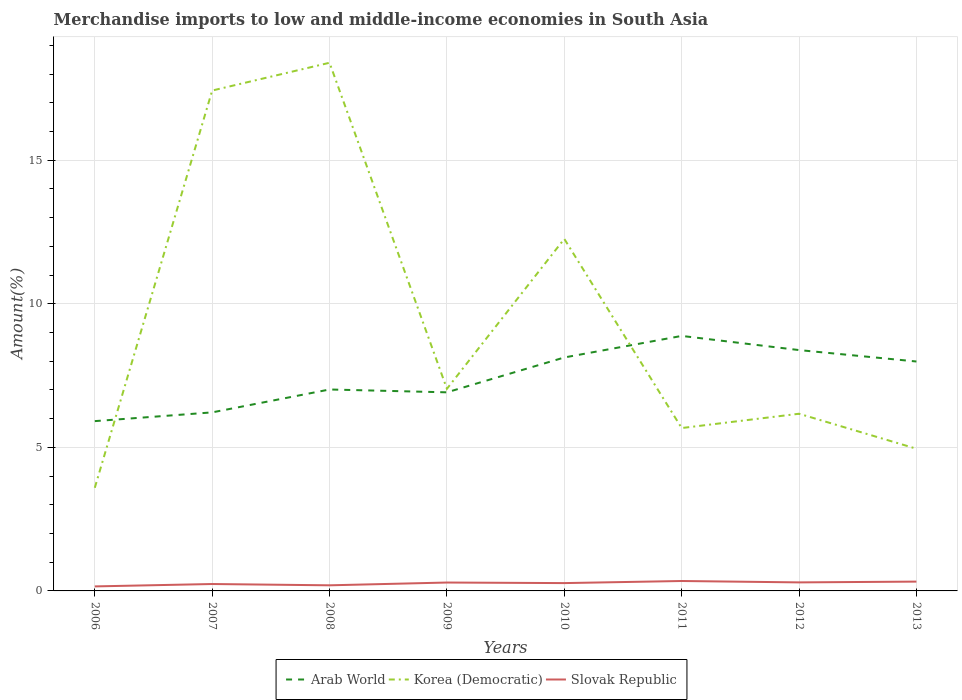Across all years, what is the maximum percentage of amount earned from merchandise imports in Arab World?
Offer a very short reply. 5.91. In which year was the percentage of amount earned from merchandise imports in Arab World maximum?
Ensure brevity in your answer.  2006. What is the total percentage of amount earned from merchandise imports in Arab World in the graph?
Make the answer very short. -1.07. What is the difference between the highest and the second highest percentage of amount earned from merchandise imports in Slovak Republic?
Offer a terse response. 0.19. Is the percentage of amount earned from merchandise imports in Arab World strictly greater than the percentage of amount earned from merchandise imports in Slovak Republic over the years?
Keep it short and to the point. No. Are the values on the major ticks of Y-axis written in scientific E-notation?
Give a very brief answer. No. Where does the legend appear in the graph?
Your response must be concise. Bottom center. How many legend labels are there?
Your response must be concise. 3. What is the title of the graph?
Provide a succinct answer. Merchandise imports to low and middle-income economies in South Asia. What is the label or title of the Y-axis?
Offer a very short reply. Amount(%). What is the Amount(%) of Arab World in 2006?
Ensure brevity in your answer.  5.91. What is the Amount(%) of Korea (Democratic) in 2006?
Ensure brevity in your answer.  3.59. What is the Amount(%) of Slovak Republic in 2006?
Your response must be concise. 0.16. What is the Amount(%) in Arab World in 2007?
Give a very brief answer. 6.22. What is the Amount(%) of Korea (Democratic) in 2007?
Provide a succinct answer. 17.43. What is the Amount(%) of Slovak Republic in 2007?
Offer a very short reply. 0.24. What is the Amount(%) of Arab World in 2008?
Provide a short and direct response. 7.01. What is the Amount(%) in Korea (Democratic) in 2008?
Your response must be concise. 18.39. What is the Amount(%) of Slovak Republic in 2008?
Keep it short and to the point. 0.2. What is the Amount(%) of Arab World in 2009?
Keep it short and to the point. 6.92. What is the Amount(%) of Korea (Democratic) in 2009?
Offer a very short reply. 7.04. What is the Amount(%) of Slovak Republic in 2009?
Ensure brevity in your answer.  0.29. What is the Amount(%) in Arab World in 2010?
Provide a succinct answer. 8.13. What is the Amount(%) of Korea (Democratic) in 2010?
Provide a short and direct response. 12.26. What is the Amount(%) of Slovak Republic in 2010?
Make the answer very short. 0.27. What is the Amount(%) in Arab World in 2011?
Offer a terse response. 8.88. What is the Amount(%) in Korea (Democratic) in 2011?
Ensure brevity in your answer.  5.67. What is the Amount(%) of Slovak Republic in 2011?
Your answer should be very brief. 0.35. What is the Amount(%) in Arab World in 2012?
Offer a very short reply. 8.39. What is the Amount(%) of Korea (Democratic) in 2012?
Ensure brevity in your answer.  6.17. What is the Amount(%) in Slovak Republic in 2012?
Ensure brevity in your answer.  0.3. What is the Amount(%) of Arab World in 2013?
Give a very brief answer. 7.99. What is the Amount(%) of Korea (Democratic) in 2013?
Provide a short and direct response. 4.95. What is the Amount(%) of Slovak Republic in 2013?
Provide a short and direct response. 0.32. Across all years, what is the maximum Amount(%) of Arab World?
Your answer should be very brief. 8.88. Across all years, what is the maximum Amount(%) in Korea (Democratic)?
Your answer should be very brief. 18.39. Across all years, what is the maximum Amount(%) of Slovak Republic?
Give a very brief answer. 0.35. Across all years, what is the minimum Amount(%) in Arab World?
Your answer should be very brief. 5.91. Across all years, what is the minimum Amount(%) of Korea (Democratic)?
Provide a short and direct response. 3.59. Across all years, what is the minimum Amount(%) of Slovak Republic?
Make the answer very short. 0.16. What is the total Amount(%) of Arab World in the graph?
Ensure brevity in your answer.  59.45. What is the total Amount(%) in Korea (Democratic) in the graph?
Provide a succinct answer. 75.5. What is the total Amount(%) in Slovak Republic in the graph?
Ensure brevity in your answer.  2.13. What is the difference between the Amount(%) of Arab World in 2006 and that in 2007?
Make the answer very short. -0.3. What is the difference between the Amount(%) of Korea (Democratic) in 2006 and that in 2007?
Give a very brief answer. -13.83. What is the difference between the Amount(%) of Slovak Republic in 2006 and that in 2007?
Ensure brevity in your answer.  -0.08. What is the difference between the Amount(%) of Arab World in 2006 and that in 2008?
Ensure brevity in your answer.  -1.1. What is the difference between the Amount(%) of Korea (Democratic) in 2006 and that in 2008?
Give a very brief answer. -14.8. What is the difference between the Amount(%) in Slovak Republic in 2006 and that in 2008?
Give a very brief answer. -0.04. What is the difference between the Amount(%) in Arab World in 2006 and that in 2009?
Offer a terse response. -1. What is the difference between the Amount(%) in Korea (Democratic) in 2006 and that in 2009?
Keep it short and to the point. -3.45. What is the difference between the Amount(%) in Slovak Republic in 2006 and that in 2009?
Your answer should be very brief. -0.13. What is the difference between the Amount(%) of Arab World in 2006 and that in 2010?
Make the answer very short. -2.22. What is the difference between the Amount(%) in Korea (Democratic) in 2006 and that in 2010?
Make the answer very short. -8.67. What is the difference between the Amount(%) of Slovak Republic in 2006 and that in 2010?
Your response must be concise. -0.12. What is the difference between the Amount(%) of Arab World in 2006 and that in 2011?
Offer a terse response. -2.97. What is the difference between the Amount(%) of Korea (Democratic) in 2006 and that in 2011?
Offer a terse response. -2.08. What is the difference between the Amount(%) in Slovak Republic in 2006 and that in 2011?
Provide a short and direct response. -0.19. What is the difference between the Amount(%) of Arab World in 2006 and that in 2012?
Provide a succinct answer. -2.47. What is the difference between the Amount(%) in Korea (Democratic) in 2006 and that in 2012?
Your response must be concise. -2.58. What is the difference between the Amount(%) of Slovak Republic in 2006 and that in 2012?
Ensure brevity in your answer.  -0.14. What is the difference between the Amount(%) of Arab World in 2006 and that in 2013?
Your answer should be compact. -2.08. What is the difference between the Amount(%) in Korea (Democratic) in 2006 and that in 2013?
Your response must be concise. -1.36. What is the difference between the Amount(%) of Slovak Republic in 2006 and that in 2013?
Provide a short and direct response. -0.17. What is the difference between the Amount(%) in Arab World in 2007 and that in 2008?
Your answer should be compact. -0.8. What is the difference between the Amount(%) in Korea (Democratic) in 2007 and that in 2008?
Provide a short and direct response. -0.97. What is the difference between the Amount(%) in Slovak Republic in 2007 and that in 2008?
Your answer should be compact. 0.05. What is the difference between the Amount(%) in Arab World in 2007 and that in 2009?
Provide a short and direct response. -0.7. What is the difference between the Amount(%) in Korea (Democratic) in 2007 and that in 2009?
Your response must be concise. 10.39. What is the difference between the Amount(%) of Slovak Republic in 2007 and that in 2009?
Provide a succinct answer. -0.05. What is the difference between the Amount(%) of Arab World in 2007 and that in 2010?
Give a very brief answer. -1.91. What is the difference between the Amount(%) in Korea (Democratic) in 2007 and that in 2010?
Give a very brief answer. 5.17. What is the difference between the Amount(%) of Slovak Republic in 2007 and that in 2010?
Your answer should be very brief. -0.03. What is the difference between the Amount(%) of Arab World in 2007 and that in 2011?
Keep it short and to the point. -2.66. What is the difference between the Amount(%) in Korea (Democratic) in 2007 and that in 2011?
Ensure brevity in your answer.  11.75. What is the difference between the Amount(%) of Slovak Republic in 2007 and that in 2011?
Provide a short and direct response. -0.1. What is the difference between the Amount(%) of Arab World in 2007 and that in 2012?
Your answer should be very brief. -2.17. What is the difference between the Amount(%) in Korea (Democratic) in 2007 and that in 2012?
Your answer should be very brief. 11.26. What is the difference between the Amount(%) in Slovak Republic in 2007 and that in 2012?
Your response must be concise. -0.06. What is the difference between the Amount(%) in Arab World in 2007 and that in 2013?
Give a very brief answer. -1.77. What is the difference between the Amount(%) in Korea (Democratic) in 2007 and that in 2013?
Your answer should be very brief. 12.47. What is the difference between the Amount(%) of Slovak Republic in 2007 and that in 2013?
Your response must be concise. -0.08. What is the difference between the Amount(%) of Arab World in 2008 and that in 2009?
Offer a very short reply. 0.1. What is the difference between the Amount(%) in Korea (Democratic) in 2008 and that in 2009?
Your response must be concise. 11.35. What is the difference between the Amount(%) in Slovak Republic in 2008 and that in 2009?
Your answer should be very brief. -0.1. What is the difference between the Amount(%) in Arab World in 2008 and that in 2010?
Make the answer very short. -1.11. What is the difference between the Amount(%) of Korea (Democratic) in 2008 and that in 2010?
Your answer should be compact. 6.13. What is the difference between the Amount(%) of Slovak Republic in 2008 and that in 2010?
Your answer should be very brief. -0.08. What is the difference between the Amount(%) in Arab World in 2008 and that in 2011?
Offer a terse response. -1.87. What is the difference between the Amount(%) in Korea (Democratic) in 2008 and that in 2011?
Provide a short and direct response. 12.72. What is the difference between the Amount(%) in Slovak Republic in 2008 and that in 2011?
Ensure brevity in your answer.  -0.15. What is the difference between the Amount(%) in Arab World in 2008 and that in 2012?
Your answer should be very brief. -1.37. What is the difference between the Amount(%) in Korea (Democratic) in 2008 and that in 2012?
Your answer should be very brief. 12.22. What is the difference between the Amount(%) of Slovak Republic in 2008 and that in 2012?
Your answer should be compact. -0.1. What is the difference between the Amount(%) in Arab World in 2008 and that in 2013?
Give a very brief answer. -0.97. What is the difference between the Amount(%) in Korea (Democratic) in 2008 and that in 2013?
Make the answer very short. 13.44. What is the difference between the Amount(%) of Slovak Republic in 2008 and that in 2013?
Provide a short and direct response. -0.13. What is the difference between the Amount(%) of Arab World in 2009 and that in 2010?
Ensure brevity in your answer.  -1.21. What is the difference between the Amount(%) of Korea (Democratic) in 2009 and that in 2010?
Give a very brief answer. -5.22. What is the difference between the Amount(%) of Slovak Republic in 2009 and that in 2010?
Your answer should be very brief. 0.02. What is the difference between the Amount(%) of Arab World in 2009 and that in 2011?
Give a very brief answer. -1.96. What is the difference between the Amount(%) of Korea (Democratic) in 2009 and that in 2011?
Provide a short and direct response. 1.37. What is the difference between the Amount(%) in Slovak Republic in 2009 and that in 2011?
Your response must be concise. -0.05. What is the difference between the Amount(%) of Arab World in 2009 and that in 2012?
Offer a terse response. -1.47. What is the difference between the Amount(%) in Korea (Democratic) in 2009 and that in 2012?
Provide a succinct answer. 0.87. What is the difference between the Amount(%) in Slovak Republic in 2009 and that in 2012?
Offer a terse response. -0.01. What is the difference between the Amount(%) in Arab World in 2009 and that in 2013?
Your response must be concise. -1.07. What is the difference between the Amount(%) of Korea (Democratic) in 2009 and that in 2013?
Your answer should be very brief. 2.09. What is the difference between the Amount(%) in Slovak Republic in 2009 and that in 2013?
Keep it short and to the point. -0.03. What is the difference between the Amount(%) in Arab World in 2010 and that in 2011?
Make the answer very short. -0.75. What is the difference between the Amount(%) of Korea (Democratic) in 2010 and that in 2011?
Your answer should be very brief. 6.59. What is the difference between the Amount(%) of Slovak Republic in 2010 and that in 2011?
Your answer should be compact. -0.07. What is the difference between the Amount(%) in Arab World in 2010 and that in 2012?
Provide a short and direct response. -0.26. What is the difference between the Amount(%) of Korea (Democratic) in 2010 and that in 2012?
Ensure brevity in your answer.  6.09. What is the difference between the Amount(%) in Slovak Republic in 2010 and that in 2012?
Give a very brief answer. -0.02. What is the difference between the Amount(%) of Arab World in 2010 and that in 2013?
Keep it short and to the point. 0.14. What is the difference between the Amount(%) in Korea (Democratic) in 2010 and that in 2013?
Your answer should be very brief. 7.31. What is the difference between the Amount(%) in Slovak Republic in 2010 and that in 2013?
Provide a succinct answer. -0.05. What is the difference between the Amount(%) in Arab World in 2011 and that in 2012?
Provide a short and direct response. 0.49. What is the difference between the Amount(%) in Korea (Democratic) in 2011 and that in 2012?
Provide a succinct answer. -0.5. What is the difference between the Amount(%) in Slovak Republic in 2011 and that in 2012?
Your response must be concise. 0.05. What is the difference between the Amount(%) in Arab World in 2011 and that in 2013?
Make the answer very short. 0.89. What is the difference between the Amount(%) in Korea (Democratic) in 2011 and that in 2013?
Give a very brief answer. 0.72. What is the difference between the Amount(%) in Slovak Republic in 2011 and that in 2013?
Give a very brief answer. 0.02. What is the difference between the Amount(%) of Arab World in 2012 and that in 2013?
Make the answer very short. 0.4. What is the difference between the Amount(%) of Korea (Democratic) in 2012 and that in 2013?
Offer a very short reply. 1.22. What is the difference between the Amount(%) in Slovak Republic in 2012 and that in 2013?
Your response must be concise. -0.03. What is the difference between the Amount(%) of Arab World in 2006 and the Amount(%) of Korea (Democratic) in 2007?
Ensure brevity in your answer.  -11.51. What is the difference between the Amount(%) in Arab World in 2006 and the Amount(%) in Slovak Republic in 2007?
Provide a short and direct response. 5.67. What is the difference between the Amount(%) of Korea (Democratic) in 2006 and the Amount(%) of Slovak Republic in 2007?
Give a very brief answer. 3.35. What is the difference between the Amount(%) in Arab World in 2006 and the Amount(%) in Korea (Democratic) in 2008?
Provide a succinct answer. -12.48. What is the difference between the Amount(%) in Arab World in 2006 and the Amount(%) in Slovak Republic in 2008?
Ensure brevity in your answer.  5.72. What is the difference between the Amount(%) of Korea (Democratic) in 2006 and the Amount(%) of Slovak Republic in 2008?
Offer a terse response. 3.4. What is the difference between the Amount(%) in Arab World in 2006 and the Amount(%) in Korea (Democratic) in 2009?
Provide a succinct answer. -1.13. What is the difference between the Amount(%) in Arab World in 2006 and the Amount(%) in Slovak Republic in 2009?
Your response must be concise. 5.62. What is the difference between the Amount(%) of Arab World in 2006 and the Amount(%) of Korea (Democratic) in 2010?
Keep it short and to the point. -6.35. What is the difference between the Amount(%) in Arab World in 2006 and the Amount(%) in Slovak Republic in 2010?
Give a very brief answer. 5.64. What is the difference between the Amount(%) in Korea (Democratic) in 2006 and the Amount(%) in Slovak Republic in 2010?
Provide a short and direct response. 3.32. What is the difference between the Amount(%) of Arab World in 2006 and the Amount(%) of Korea (Democratic) in 2011?
Make the answer very short. 0.24. What is the difference between the Amount(%) of Arab World in 2006 and the Amount(%) of Slovak Republic in 2011?
Your answer should be compact. 5.57. What is the difference between the Amount(%) in Korea (Democratic) in 2006 and the Amount(%) in Slovak Republic in 2011?
Make the answer very short. 3.25. What is the difference between the Amount(%) in Arab World in 2006 and the Amount(%) in Korea (Democratic) in 2012?
Your response must be concise. -0.26. What is the difference between the Amount(%) in Arab World in 2006 and the Amount(%) in Slovak Republic in 2012?
Provide a short and direct response. 5.62. What is the difference between the Amount(%) in Korea (Democratic) in 2006 and the Amount(%) in Slovak Republic in 2012?
Make the answer very short. 3.29. What is the difference between the Amount(%) in Arab World in 2006 and the Amount(%) in Slovak Republic in 2013?
Offer a very short reply. 5.59. What is the difference between the Amount(%) of Korea (Democratic) in 2006 and the Amount(%) of Slovak Republic in 2013?
Provide a short and direct response. 3.27. What is the difference between the Amount(%) of Arab World in 2007 and the Amount(%) of Korea (Democratic) in 2008?
Your answer should be very brief. -12.18. What is the difference between the Amount(%) in Arab World in 2007 and the Amount(%) in Slovak Republic in 2008?
Offer a very short reply. 6.02. What is the difference between the Amount(%) of Korea (Democratic) in 2007 and the Amount(%) of Slovak Republic in 2008?
Keep it short and to the point. 17.23. What is the difference between the Amount(%) of Arab World in 2007 and the Amount(%) of Korea (Democratic) in 2009?
Your response must be concise. -0.82. What is the difference between the Amount(%) in Arab World in 2007 and the Amount(%) in Slovak Republic in 2009?
Provide a succinct answer. 5.93. What is the difference between the Amount(%) in Korea (Democratic) in 2007 and the Amount(%) in Slovak Republic in 2009?
Your response must be concise. 17.13. What is the difference between the Amount(%) of Arab World in 2007 and the Amount(%) of Korea (Democratic) in 2010?
Your answer should be compact. -6.04. What is the difference between the Amount(%) of Arab World in 2007 and the Amount(%) of Slovak Republic in 2010?
Offer a terse response. 5.95. What is the difference between the Amount(%) in Korea (Democratic) in 2007 and the Amount(%) in Slovak Republic in 2010?
Give a very brief answer. 17.15. What is the difference between the Amount(%) in Arab World in 2007 and the Amount(%) in Korea (Democratic) in 2011?
Your response must be concise. 0.55. What is the difference between the Amount(%) in Arab World in 2007 and the Amount(%) in Slovak Republic in 2011?
Make the answer very short. 5.87. What is the difference between the Amount(%) of Korea (Democratic) in 2007 and the Amount(%) of Slovak Republic in 2011?
Your response must be concise. 17.08. What is the difference between the Amount(%) in Arab World in 2007 and the Amount(%) in Korea (Democratic) in 2012?
Offer a very short reply. 0.05. What is the difference between the Amount(%) of Arab World in 2007 and the Amount(%) of Slovak Republic in 2012?
Your answer should be very brief. 5.92. What is the difference between the Amount(%) in Korea (Democratic) in 2007 and the Amount(%) in Slovak Republic in 2012?
Keep it short and to the point. 17.13. What is the difference between the Amount(%) in Arab World in 2007 and the Amount(%) in Korea (Democratic) in 2013?
Your response must be concise. 1.27. What is the difference between the Amount(%) in Arab World in 2007 and the Amount(%) in Slovak Republic in 2013?
Offer a terse response. 5.89. What is the difference between the Amount(%) in Korea (Democratic) in 2007 and the Amount(%) in Slovak Republic in 2013?
Give a very brief answer. 17.1. What is the difference between the Amount(%) in Arab World in 2008 and the Amount(%) in Korea (Democratic) in 2009?
Make the answer very short. -0.02. What is the difference between the Amount(%) in Arab World in 2008 and the Amount(%) in Slovak Republic in 2009?
Keep it short and to the point. 6.72. What is the difference between the Amount(%) of Korea (Democratic) in 2008 and the Amount(%) of Slovak Republic in 2009?
Provide a succinct answer. 18.1. What is the difference between the Amount(%) of Arab World in 2008 and the Amount(%) of Korea (Democratic) in 2010?
Your response must be concise. -5.24. What is the difference between the Amount(%) in Arab World in 2008 and the Amount(%) in Slovak Republic in 2010?
Your answer should be compact. 6.74. What is the difference between the Amount(%) in Korea (Democratic) in 2008 and the Amount(%) in Slovak Republic in 2010?
Offer a very short reply. 18.12. What is the difference between the Amount(%) in Arab World in 2008 and the Amount(%) in Korea (Democratic) in 2011?
Keep it short and to the point. 1.34. What is the difference between the Amount(%) in Arab World in 2008 and the Amount(%) in Slovak Republic in 2011?
Provide a succinct answer. 6.67. What is the difference between the Amount(%) of Korea (Democratic) in 2008 and the Amount(%) of Slovak Republic in 2011?
Your answer should be compact. 18.05. What is the difference between the Amount(%) of Arab World in 2008 and the Amount(%) of Korea (Democratic) in 2012?
Offer a terse response. 0.84. What is the difference between the Amount(%) in Arab World in 2008 and the Amount(%) in Slovak Republic in 2012?
Make the answer very short. 6.72. What is the difference between the Amount(%) in Korea (Democratic) in 2008 and the Amount(%) in Slovak Republic in 2012?
Your answer should be very brief. 18.1. What is the difference between the Amount(%) of Arab World in 2008 and the Amount(%) of Korea (Democratic) in 2013?
Provide a succinct answer. 2.06. What is the difference between the Amount(%) of Arab World in 2008 and the Amount(%) of Slovak Republic in 2013?
Make the answer very short. 6.69. What is the difference between the Amount(%) of Korea (Democratic) in 2008 and the Amount(%) of Slovak Republic in 2013?
Provide a short and direct response. 18.07. What is the difference between the Amount(%) of Arab World in 2009 and the Amount(%) of Korea (Democratic) in 2010?
Your response must be concise. -5.34. What is the difference between the Amount(%) in Arab World in 2009 and the Amount(%) in Slovak Republic in 2010?
Make the answer very short. 6.64. What is the difference between the Amount(%) of Korea (Democratic) in 2009 and the Amount(%) of Slovak Republic in 2010?
Your response must be concise. 6.77. What is the difference between the Amount(%) of Arab World in 2009 and the Amount(%) of Korea (Democratic) in 2011?
Provide a short and direct response. 1.24. What is the difference between the Amount(%) of Arab World in 2009 and the Amount(%) of Slovak Republic in 2011?
Keep it short and to the point. 6.57. What is the difference between the Amount(%) in Korea (Democratic) in 2009 and the Amount(%) in Slovak Republic in 2011?
Keep it short and to the point. 6.69. What is the difference between the Amount(%) of Arab World in 2009 and the Amount(%) of Korea (Democratic) in 2012?
Provide a succinct answer. 0.75. What is the difference between the Amount(%) in Arab World in 2009 and the Amount(%) in Slovak Republic in 2012?
Give a very brief answer. 6.62. What is the difference between the Amount(%) in Korea (Democratic) in 2009 and the Amount(%) in Slovak Republic in 2012?
Your answer should be very brief. 6.74. What is the difference between the Amount(%) of Arab World in 2009 and the Amount(%) of Korea (Democratic) in 2013?
Give a very brief answer. 1.96. What is the difference between the Amount(%) of Arab World in 2009 and the Amount(%) of Slovak Republic in 2013?
Your answer should be very brief. 6.59. What is the difference between the Amount(%) in Korea (Democratic) in 2009 and the Amount(%) in Slovak Republic in 2013?
Your response must be concise. 6.71. What is the difference between the Amount(%) in Arab World in 2010 and the Amount(%) in Korea (Democratic) in 2011?
Your answer should be compact. 2.46. What is the difference between the Amount(%) in Arab World in 2010 and the Amount(%) in Slovak Republic in 2011?
Provide a succinct answer. 7.78. What is the difference between the Amount(%) of Korea (Democratic) in 2010 and the Amount(%) of Slovak Republic in 2011?
Offer a terse response. 11.91. What is the difference between the Amount(%) in Arab World in 2010 and the Amount(%) in Korea (Democratic) in 2012?
Ensure brevity in your answer.  1.96. What is the difference between the Amount(%) in Arab World in 2010 and the Amount(%) in Slovak Republic in 2012?
Offer a very short reply. 7.83. What is the difference between the Amount(%) of Korea (Democratic) in 2010 and the Amount(%) of Slovak Republic in 2012?
Provide a succinct answer. 11.96. What is the difference between the Amount(%) in Arab World in 2010 and the Amount(%) in Korea (Democratic) in 2013?
Provide a short and direct response. 3.18. What is the difference between the Amount(%) of Arab World in 2010 and the Amount(%) of Slovak Republic in 2013?
Provide a succinct answer. 7.81. What is the difference between the Amount(%) of Korea (Democratic) in 2010 and the Amount(%) of Slovak Republic in 2013?
Make the answer very short. 11.93. What is the difference between the Amount(%) in Arab World in 2011 and the Amount(%) in Korea (Democratic) in 2012?
Offer a terse response. 2.71. What is the difference between the Amount(%) in Arab World in 2011 and the Amount(%) in Slovak Republic in 2012?
Keep it short and to the point. 8.58. What is the difference between the Amount(%) in Korea (Democratic) in 2011 and the Amount(%) in Slovak Republic in 2012?
Your answer should be compact. 5.37. What is the difference between the Amount(%) of Arab World in 2011 and the Amount(%) of Korea (Democratic) in 2013?
Offer a very short reply. 3.93. What is the difference between the Amount(%) of Arab World in 2011 and the Amount(%) of Slovak Republic in 2013?
Provide a short and direct response. 8.56. What is the difference between the Amount(%) in Korea (Democratic) in 2011 and the Amount(%) in Slovak Republic in 2013?
Provide a succinct answer. 5.35. What is the difference between the Amount(%) of Arab World in 2012 and the Amount(%) of Korea (Democratic) in 2013?
Provide a succinct answer. 3.44. What is the difference between the Amount(%) of Arab World in 2012 and the Amount(%) of Slovak Republic in 2013?
Give a very brief answer. 8.06. What is the difference between the Amount(%) in Korea (Democratic) in 2012 and the Amount(%) in Slovak Republic in 2013?
Offer a terse response. 5.85. What is the average Amount(%) in Arab World per year?
Your answer should be very brief. 7.43. What is the average Amount(%) in Korea (Democratic) per year?
Your response must be concise. 9.44. What is the average Amount(%) of Slovak Republic per year?
Give a very brief answer. 0.27. In the year 2006, what is the difference between the Amount(%) in Arab World and Amount(%) in Korea (Democratic)?
Offer a terse response. 2.32. In the year 2006, what is the difference between the Amount(%) in Arab World and Amount(%) in Slovak Republic?
Make the answer very short. 5.76. In the year 2006, what is the difference between the Amount(%) in Korea (Democratic) and Amount(%) in Slovak Republic?
Make the answer very short. 3.43. In the year 2007, what is the difference between the Amount(%) in Arab World and Amount(%) in Korea (Democratic)?
Your answer should be very brief. -11.21. In the year 2007, what is the difference between the Amount(%) of Arab World and Amount(%) of Slovak Republic?
Ensure brevity in your answer.  5.98. In the year 2007, what is the difference between the Amount(%) in Korea (Democratic) and Amount(%) in Slovak Republic?
Make the answer very short. 17.18. In the year 2008, what is the difference between the Amount(%) in Arab World and Amount(%) in Korea (Democratic)?
Provide a short and direct response. -11.38. In the year 2008, what is the difference between the Amount(%) in Arab World and Amount(%) in Slovak Republic?
Keep it short and to the point. 6.82. In the year 2008, what is the difference between the Amount(%) of Korea (Democratic) and Amount(%) of Slovak Republic?
Your response must be concise. 18.2. In the year 2009, what is the difference between the Amount(%) of Arab World and Amount(%) of Korea (Democratic)?
Offer a terse response. -0.12. In the year 2009, what is the difference between the Amount(%) in Arab World and Amount(%) in Slovak Republic?
Your response must be concise. 6.62. In the year 2009, what is the difference between the Amount(%) in Korea (Democratic) and Amount(%) in Slovak Republic?
Make the answer very short. 6.75. In the year 2010, what is the difference between the Amount(%) of Arab World and Amount(%) of Korea (Democratic)?
Provide a short and direct response. -4.13. In the year 2010, what is the difference between the Amount(%) of Arab World and Amount(%) of Slovak Republic?
Give a very brief answer. 7.86. In the year 2010, what is the difference between the Amount(%) of Korea (Democratic) and Amount(%) of Slovak Republic?
Keep it short and to the point. 11.99. In the year 2011, what is the difference between the Amount(%) in Arab World and Amount(%) in Korea (Democratic)?
Offer a very short reply. 3.21. In the year 2011, what is the difference between the Amount(%) of Arab World and Amount(%) of Slovak Republic?
Give a very brief answer. 8.53. In the year 2011, what is the difference between the Amount(%) of Korea (Democratic) and Amount(%) of Slovak Republic?
Provide a short and direct response. 5.33. In the year 2012, what is the difference between the Amount(%) of Arab World and Amount(%) of Korea (Democratic)?
Make the answer very short. 2.22. In the year 2012, what is the difference between the Amount(%) of Arab World and Amount(%) of Slovak Republic?
Your answer should be compact. 8.09. In the year 2012, what is the difference between the Amount(%) of Korea (Democratic) and Amount(%) of Slovak Republic?
Offer a very short reply. 5.87. In the year 2013, what is the difference between the Amount(%) of Arab World and Amount(%) of Korea (Democratic)?
Your response must be concise. 3.04. In the year 2013, what is the difference between the Amount(%) in Arab World and Amount(%) in Slovak Republic?
Your answer should be compact. 7.67. In the year 2013, what is the difference between the Amount(%) of Korea (Democratic) and Amount(%) of Slovak Republic?
Keep it short and to the point. 4.63. What is the ratio of the Amount(%) of Arab World in 2006 to that in 2007?
Your response must be concise. 0.95. What is the ratio of the Amount(%) of Korea (Democratic) in 2006 to that in 2007?
Your answer should be compact. 0.21. What is the ratio of the Amount(%) of Slovak Republic in 2006 to that in 2007?
Your response must be concise. 0.65. What is the ratio of the Amount(%) of Arab World in 2006 to that in 2008?
Make the answer very short. 0.84. What is the ratio of the Amount(%) of Korea (Democratic) in 2006 to that in 2008?
Make the answer very short. 0.2. What is the ratio of the Amount(%) in Slovak Republic in 2006 to that in 2008?
Provide a succinct answer. 0.81. What is the ratio of the Amount(%) in Arab World in 2006 to that in 2009?
Your answer should be compact. 0.85. What is the ratio of the Amount(%) in Korea (Democratic) in 2006 to that in 2009?
Your response must be concise. 0.51. What is the ratio of the Amount(%) of Slovak Republic in 2006 to that in 2009?
Provide a short and direct response. 0.54. What is the ratio of the Amount(%) of Arab World in 2006 to that in 2010?
Ensure brevity in your answer.  0.73. What is the ratio of the Amount(%) in Korea (Democratic) in 2006 to that in 2010?
Offer a terse response. 0.29. What is the ratio of the Amount(%) of Slovak Republic in 2006 to that in 2010?
Offer a terse response. 0.58. What is the ratio of the Amount(%) in Arab World in 2006 to that in 2011?
Offer a very short reply. 0.67. What is the ratio of the Amount(%) in Korea (Democratic) in 2006 to that in 2011?
Provide a succinct answer. 0.63. What is the ratio of the Amount(%) of Slovak Republic in 2006 to that in 2011?
Make the answer very short. 0.46. What is the ratio of the Amount(%) of Arab World in 2006 to that in 2012?
Offer a very short reply. 0.7. What is the ratio of the Amount(%) in Korea (Democratic) in 2006 to that in 2012?
Give a very brief answer. 0.58. What is the ratio of the Amount(%) of Slovak Republic in 2006 to that in 2012?
Offer a very short reply. 0.53. What is the ratio of the Amount(%) in Arab World in 2006 to that in 2013?
Give a very brief answer. 0.74. What is the ratio of the Amount(%) in Korea (Democratic) in 2006 to that in 2013?
Keep it short and to the point. 0.73. What is the ratio of the Amount(%) of Slovak Republic in 2006 to that in 2013?
Your answer should be compact. 0.49. What is the ratio of the Amount(%) of Arab World in 2007 to that in 2008?
Your answer should be very brief. 0.89. What is the ratio of the Amount(%) in Slovak Republic in 2007 to that in 2008?
Offer a very short reply. 1.23. What is the ratio of the Amount(%) of Arab World in 2007 to that in 2009?
Offer a terse response. 0.9. What is the ratio of the Amount(%) of Korea (Democratic) in 2007 to that in 2009?
Provide a succinct answer. 2.48. What is the ratio of the Amount(%) of Slovak Republic in 2007 to that in 2009?
Provide a short and direct response. 0.82. What is the ratio of the Amount(%) in Arab World in 2007 to that in 2010?
Offer a terse response. 0.76. What is the ratio of the Amount(%) in Korea (Democratic) in 2007 to that in 2010?
Provide a short and direct response. 1.42. What is the ratio of the Amount(%) of Slovak Republic in 2007 to that in 2010?
Offer a terse response. 0.88. What is the ratio of the Amount(%) of Arab World in 2007 to that in 2011?
Your response must be concise. 0.7. What is the ratio of the Amount(%) of Korea (Democratic) in 2007 to that in 2011?
Give a very brief answer. 3.07. What is the ratio of the Amount(%) in Slovak Republic in 2007 to that in 2011?
Offer a very short reply. 0.7. What is the ratio of the Amount(%) of Arab World in 2007 to that in 2012?
Provide a short and direct response. 0.74. What is the ratio of the Amount(%) in Korea (Democratic) in 2007 to that in 2012?
Your answer should be very brief. 2.82. What is the ratio of the Amount(%) in Slovak Republic in 2007 to that in 2012?
Keep it short and to the point. 0.81. What is the ratio of the Amount(%) of Arab World in 2007 to that in 2013?
Make the answer very short. 0.78. What is the ratio of the Amount(%) in Korea (Democratic) in 2007 to that in 2013?
Make the answer very short. 3.52. What is the ratio of the Amount(%) in Slovak Republic in 2007 to that in 2013?
Make the answer very short. 0.74. What is the ratio of the Amount(%) in Arab World in 2008 to that in 2009?
Your response must be concise. 1.01. What is the ratio of the Amount(%) of Korea (Democratic) in 2008 to that in 2009?
Give a very brief answer. 2.61. What is the ratio of the Amount(%) in Slovak Republic in 2008 to that in 2009?
Ensure brevity in your answer.  0.67. What is the ratio of the Amount(%) in Arab World in 2008 to that in 2010?
Provide a succinct answer. 0.86. What is the ratio of the Amount(%) in Korea (Democratic) in 2008 to that in 2010?
Provide a succinct answer. 1.5. What is the ratio of the Amount(%) in Slovak Republic in 2008 to that in 2010?
Give a very brief answer. 0.72. What is the ratio of the Amount(%) in Arab World in 2008 to that in 2011?
Offer a terse response. 0.79. What is the ratio of the Amount(%) in Korea (Democratic) in 2008 to that in 2011?
Your answer should be very brief. 3.24. What is the ratio of the Amount(%) of Slovak Republic in 2008 to that in 2011?
Provide a succinct answer. 0.57. What is the ratio of the Amount(%) of Arab World in 2008 to that in 2012?
Provide a short and direct response. 0.84. What is the ratio of the Amount(%) of Korea (Democratic) in 2008 to that in 2012?
Provide a short and direct response. 2.98. What is the ratio of the Amount(%) in Slovak Republic in 2008 to that in 2012?
Your answer should be very brief. 0.66. What is the ratio of the Amount(%) of Arab World in 2008 to that in 2013?
Give a very brief answer. 0.88. What is the ratio of the Amount(%) of Korea (Democratic) in 2008 to that in 2013?
Offer a terse response. 3.71. What is the ratio of the Amount(%) in Slovak Republic in 2008 to that in 2013?
Keep it short and to the point. 0.6. What is the ratio of the Amount(%) in Arab World in 2009 to that in 2010?
Offer a very short reply. 0.85. What is the ratio of the Amount(%) in Korea (Democratic) in 2009 to that in 2010?
Make the answer very short. 0.57. What is the ratio of the Amount(%) in Slovak Republic in 2009 to that in 2010?
Give a very brief answer. 1.07. What is the ratio of the Amount(%) of Arab World in 2009 to that in 2011?
Offer a terse response. 0.78. What is the ratio of the Amount(%) in Korea (Democratic) in 2009 to that in 2011?
Your answer should be compact. 1.24. What is the ratio of the Amount(%) in Slovak Republic in 2009 to that in 2011?
Your answer should be very brief. 0.84. What is the ratio of the Amount(%) in Arab World in 2009 to that in 2012?
Offer a terse response. 0.82. What is the ratio of the Amount(%) in Korea (Democratic) in 2009 to that in 2012?
Provide a short and direct response. 1.14. What is the ratio of the Amount(%) of Slovak Republic in 2009 to that in 2012?
Your response must be concise. 0.98. What is the ratio of the Amount(%) in Arab World in 2009 to that in 2013?
Offer a terse response. 0.87. What is the ratio of the Amount(%) in Korea (Democratic) in 2009 to that in 2013?
Your response must be concise. 1.42. What is the ratio of the Amount(%) of Slovak Republic in 2009 to that in 2013?
Your answer should be compact. 0.9. What is the ratio of the Amount(%) of Arab World in 2010 to that in 2011?
Provide a short and direct response. 0.92. What is the ratio of the Amount(%) in Korea (Democratic) in 2010 to that in 2011?
Offer a terse response. 2.16. What is the ratio of the Amount(%) of Slovak Republic in 2010 to that in 2011?
Offer a very short reply. 0.79. What is the ratio of the Amount(%) in Arab World in 2010 to that in 2012?
Offer a terse response. 0.97. What is the ratio of the Amount(%) of Korea (Democratic) in 2010 to that in 2012?
Ensure brevity in your answer.  1.99. What is the ratio of the Amount(%) of Slovak Republic in 2010 to that in 2012?
Ensure brevity in your answer.  0.92. What is the ratio of the Amount(%) of Arab World in 2010 to that in 2013?
Ensure brevity in your answer.  1.02. What is the ratio of the Amount(%) of Korea (Democratic) in 2010 to that in 2013?
Offer a very short reply. 2.48. What is the ratio of the Amount(%) in Slovak Republic in 2010 to that in 2013?
Your answer should be compact. 0.84. What is the ratio of the Amount(%) of Arab World in 2011 to that in 2012?
Give a very brief answer. 1.06. What is the ratio of the Amount(%) of Korea (Democratic) in 2011 to that in 2012?
Offer a very short reply. 0.92. What is the ratio of the Amount(%) of Slovak Republic in 2011 to that in 2012?
Provide a short and direct response. 1.16. What is the ratio of the Amount(%) of Arab World in 2011 to that in 2013?
Provide a succinct answer. 1.11. What is the ratio of the Amount(%) in Korea (Democratic) in 2011 to that in 2013?
Offer a very short reply. 1.15. What is the ratio of the Amount(%) in Slovak Republic in 2011 to that in 2013?
Give a very brief answer. 1.06. What is the ratio of the Amount(%) in Arab World in 2012 to that in 2013?
Your answer should be very brief. 1.05. What is the ratio of the Amount(%) of Korea (Democratic) in 2012 to that in 2013?
Offer a terse response. 1.25. What is the ratio of the Amount(%) of Slovak Republic in 2012 to that in 2013?
Your response must be concise. 0.92. What is the difference between the highest and the second highest Amount(%) in Arab World?
Your answer should be very brief. 0.49. What is the difference between the highest and the second highest Amount(%) in Slovak Republic?
Offer a very short reply. 0.02. What is the difference between the highest and the lowest Amount(%) of Arab World?
Your answer should be compact. 2.97. What is the difference between the highest and the lowest Amount(%) of Korea (Democratic)?
Offer a terse response. 14.8. What is the difference between the highest and the lowest Amount(%) in Slovak Republic?
Offer a terse response. 0.19. 